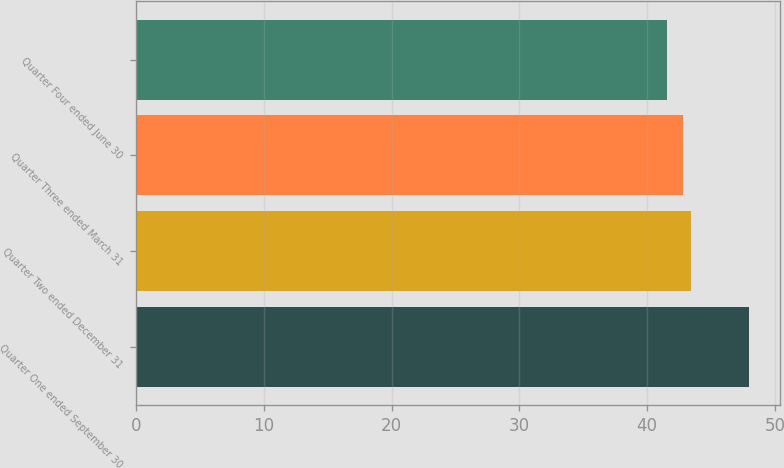<chart> <loc_0><loc_0><loc_500><loc_500><bar_chart><fcel>Quarter One ended September 30<fcel>Quarter Two ended December 31<fcel>Quarter Three ended March 31<fcel>Quarter Four ended June 30<nl><fcel>47.98<fcel>43.45<fcel>42.81<fcel>41.56<nl></chart> 